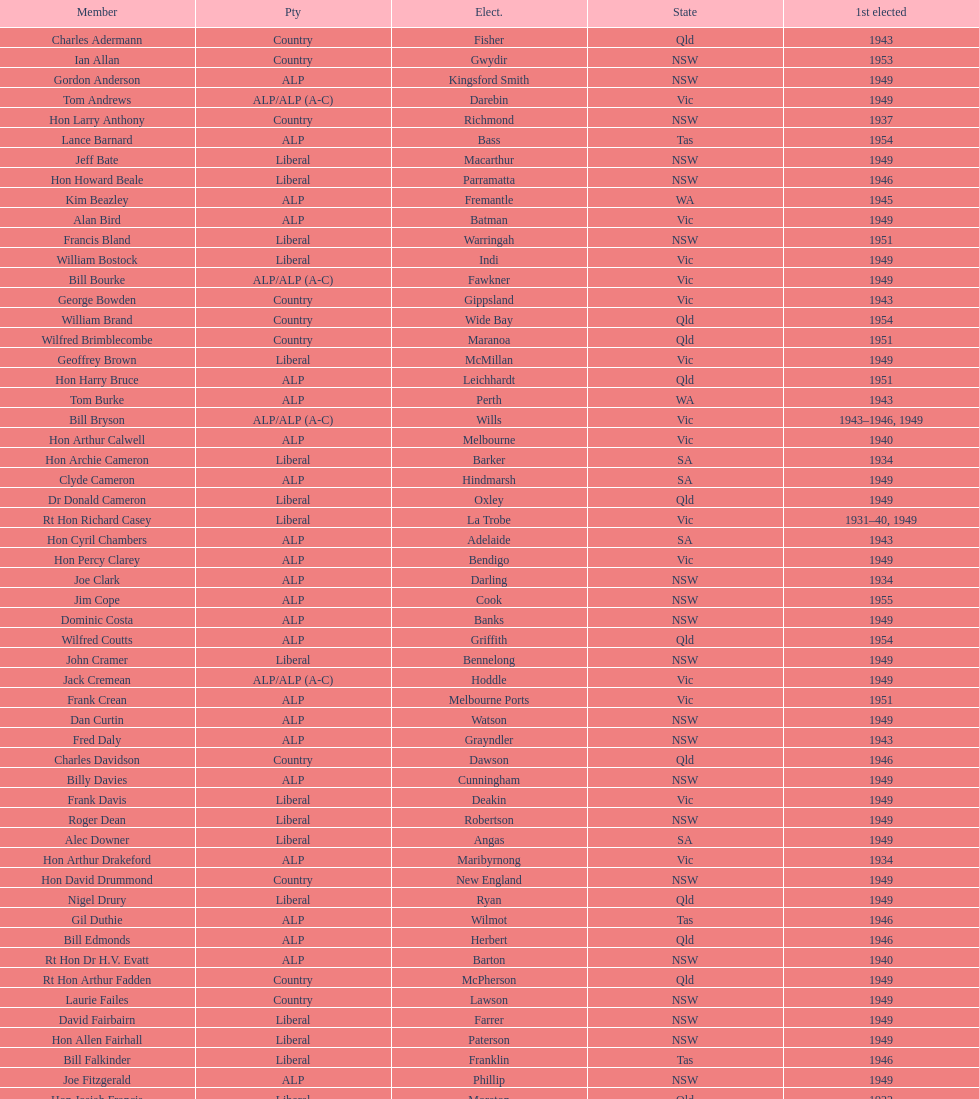Which party was elected the least? Country. 